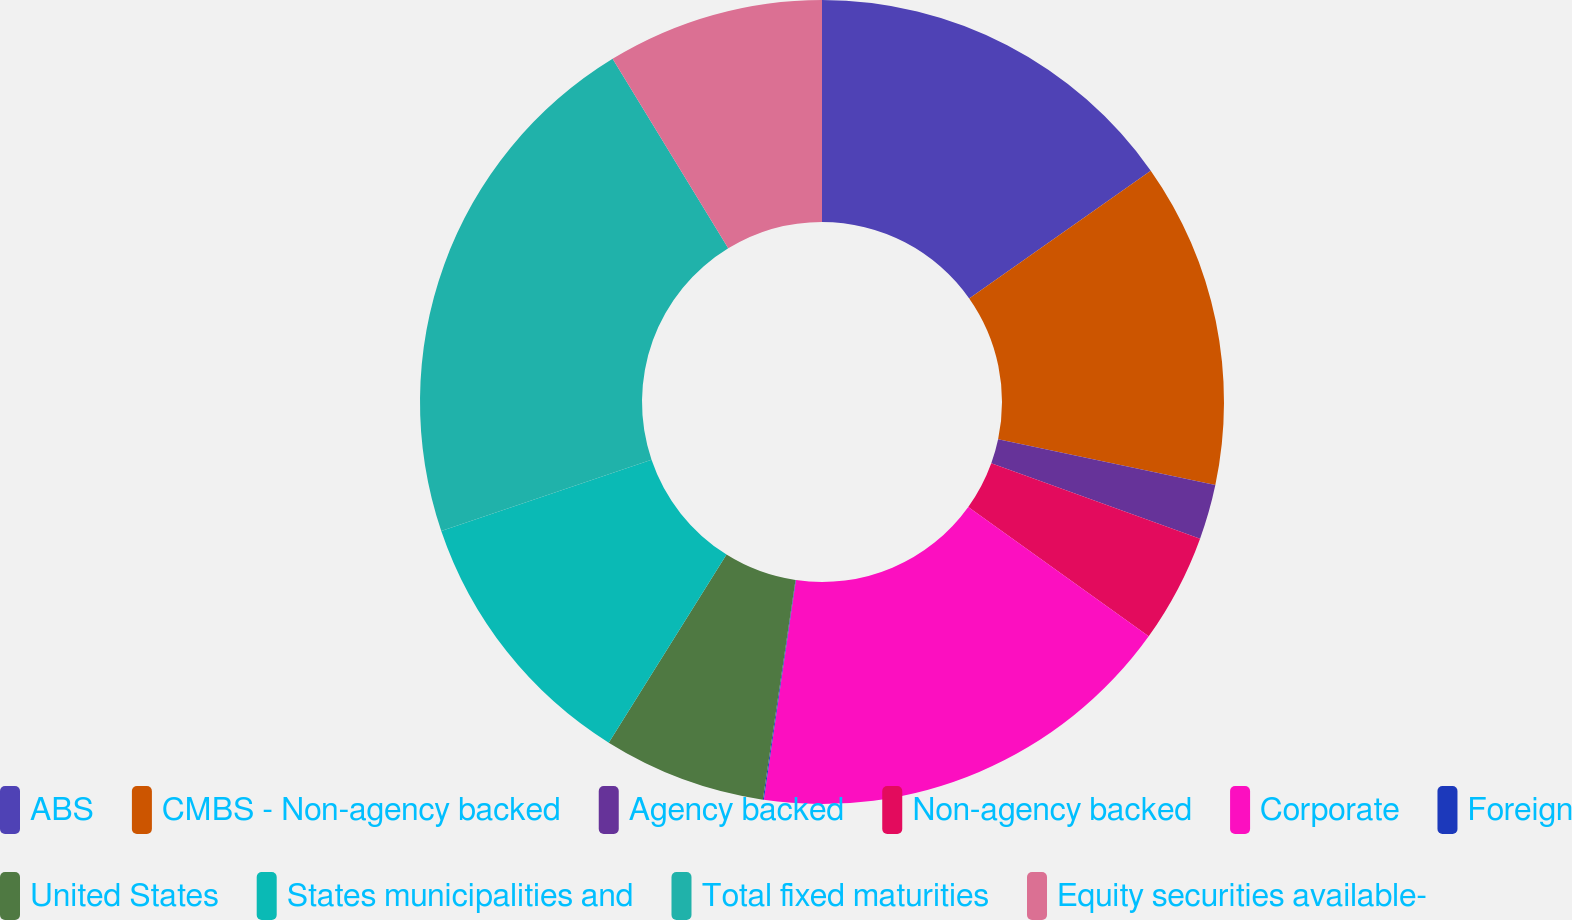Convert chart to OTSL. <chart><loc_0><loc_0><loc_500><loc_500><pie_chart><fcel>ABS<fcel>CMBS - Non-agency backed<fcel>Agency backed<fcel>Non-agency backed<fcel>Corporate<fcel>Foreign<fcel>United States<fcel>States municipalities and<fcel>Total fixed maturities<fcel>Equity securities available-<nl><fcel>15.24%<fcel>13.07%<fcel>2.21%<fcel>4.38%<fcel>17.41%<fcel>0.04%<fcel>6.55%<fcel>10.9%<fcel>21.48%<fcel>8.72%<nl></chart> 